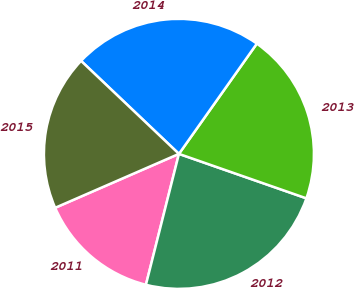Convert chart to OTSL. <chart><loc_0><loc_0><loc_500><loc_500><pie_chart><fcel>2011<fcel>2012<fcel>2013<fcel>2014<fcel>2015<nl><fcel>14.53%<fcel>23.59%<fcel>20.55%<fcel>22.7%<fcel>18.63%<nl></chart> 